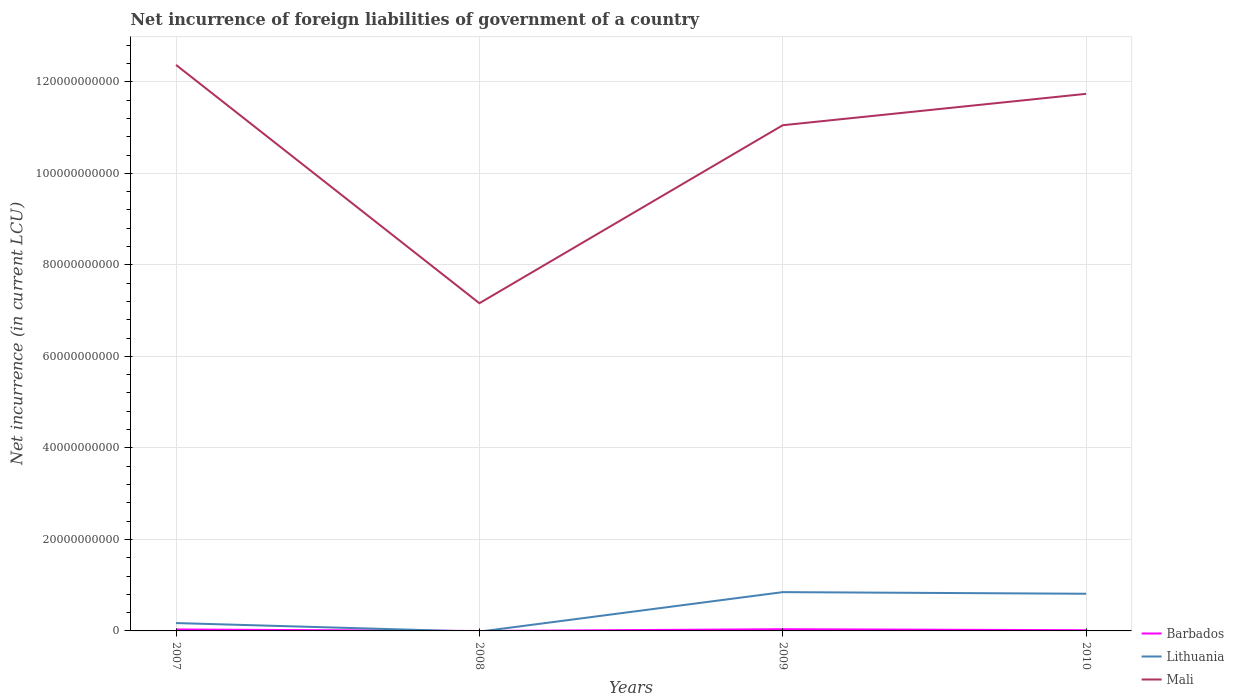How many different coloured lines are there?
Provide a succinct answer. 3. Across all years, what is the maximum net incurrence of foreign liabilities in Barbados?
Ensure brevity in your answer.  0. What is the total net incurrence of foreign liabilities in Mali in the graph?
Ensure brevity in your answer.  1.32e+1. What is the difference between the highest and the second highest net incurrence of foreign liabilities in Lithuania?
Give a very brief answer. 8.48e+09. What is the difference between the highest and the lowest net incurrence of foreign liabilities in Barbados?
Provide a succinct answer. 2. Is the net incurrence of foreign liabilities in Lithuania strictly greater than the net incurrence of foreign liabilities in Barbados over the years?
Give a very brief answer. No. What is the difference between two consecutive major ticks on the Y-axis?
Make the answer very short. 2.00e+1. Are the values on the major ticks of Y-axis written in scientific E-notation?
Offer a very short reply. No. Does the graph contain any zero values?
Ensure brevity in your answer.  Yes. Does the graph contain grids?
Give a very brief answer. Yes. How many legend labels are there?
Make the answer very short. 3. How are the legend labels stacked?
Offer a terse response. Vertical. What is the title of the graph?
Offer a terse response. Net incurrence of foreign liabilities of government of a country. Does "Turkey" appear as one of the legend labels in the graph?
Ensure brevity in your answer.  No. What is the label or title of the Y-axis?
Give a very brief answer. Net incurrence (in current LCU). What is the Net incurrence (in current LCU) in Barbados in 2007?
Your answer should be compact. 3.19e+08. What is the Net incurrence (in current LCU) in Lithuania in 2007?
Give a very brief answer. 1.72e+09. What is the Net incurrence (in current LCU) in Mali in 2007?
Keep it short and to the point. 1.24e+11. What is the Net incurrence (in current LCU) of Barbados in 2008?
Offer a terse response. 0. What is the Net incurrence (in current LCU) of Lithuania in 2008?
Keep it short and to the point. 0. What is the Net incurrence (in current LCU) of Mali in 2008?
Give a very brief answer. 7.16e+1. What is the Net incurrence (in current LCU) in Barbados in 2009?
Offer a very short reply. 3.75e+08. What is the Net incurrence (in current LCU) in Lithuania in 2009?
Offer a very short reply. 8.48e+09. What is the Net incurrence (in current LCU) of Mali in 2009?
Offer a terse response. 1.11e+11. What is the Net incurrence (in current LCU) of Barbados in 2010?
Keep it short and to the point. 1.54e+08. What is the Net incurrence (in current LCU) of Lithuania in 2010?
Offer a very short reply. 8.12e+09. What is the Net incurrence (in current LCU) of Mali in 2010?
Your answer should be very brief. 1.17e+11. Across all years, what is the maximum Net incurrence (in current LCU) of Barbados?
Your response must be concise. 3.75e+08. Across all years, what is the maximum Net incurrence (in current LCU) in Lithuania?
Provide a succinct answer. 8.48e+09. Across all years, what is the maximum Net incurrence (in current LCU) of Mali?
Provide a short and direct response. 1.24e+11. Across all years, what is the minimum Net incurrence (in current LCU) of Lithuania?
Provide a succinct answer. 0. Across all years, what is the minimum Net incurrence (in current LCU) of Mali?
Ensure brevity in your answer.  7.16e+1. What is the total Net incurrence (in current LCU) of Barbados in the graph?
Make the answer very short. 8.48e+08. What is the total Net incurrence (in current LCU) in Lithuania in the graph?
Keep it short and to the point. 1.83e+1. What is the total Net incurrence (in current LCU) in Mali in the graph?
Ensure brevity in your answer.  4.23e+11. What is the difference between the Net incurrence (in current LCU) of Mali in 2007 and that in 2008?
Your response must be concise. 5.21e+1. What is the difference between the Net incurrence (in current LCU) of Barbados in 2007 and that in 2009?
Your answer should be very brief. -5.55e+07. What is the difference between the Net incurrence (in current LCU) in Lithuania in 2007 and that in 2009?
Make the answer very short. -6.76e+09. What is the difference between the Net incurrence (in current LCU) in Mali in 2007 and that in 2009?
Your answer should be compact. 1.32e+1. What is the difference between the Net incurrence (in current LCU) in Barbados in 2007 and that in 2010?
Your answer should be very brief. 1.65e+08. What is the difference between the Net incurrence (in current LCU) of Lithuania in 2007 and that in 2010?
Make the answer very short. -6.40e+09. What is the difference between the Net incurrence (in current LCU) in Mali in 2007 and that in 2010?
Offer a terse response. 6.32e+09. What is the difference between the Net incurrence (in current LCU) of Mali in 2008 and that in 2009?
Offer a very short reply. -3.89e+1. What is the difference between the Net incurrence (in current LCU) in Mali in 2008 and that in 2010?
Provide a succinct answer. -4.58e+1. What is the difference between the Net incurrence (in current LCU) in Barbados in 2009 and that in 2010?
Give a very brief answer. 2.20e+08. What is the difference between the Net incurrence (in current LCU) in Lithuania in 2009 and that in 2010?
Provide a succinct answer. 3.56e+08. What is the difference between the Net incurrence (in current LCU) in Mali in 2009 and that in 2010?
Make the answer very short. -6.86e+09. What is the difference between the Net incurrence (in current LCU) in Barbados in 2007 and the Net incurrence (in current LCU) in Mali in 2008?
Ensure brevity in your answer.  -7.13e+1. What is the difference between the Net incurrence (in current LCU) of Lithuania in 2007 and the Net incurrence (in current LCU) of Mali in 2008?
Make the answer very short. -6.99e+1. What is the difference between the Net incurrence (in current LCU) of Barbados in 2007 and the Net incurrence (in current LCU) of Lithuania in 2009?
Offer a terse response. -8.16e+09. What is the difference between the Net incurrence (in current LCU) in Barbados in 2007 and the Net incurrence (in current LCU) in Mali in 2009?
Offer a terse response. -1.10e+11. What is the difference between the Net incurrence (in current LCU) in Lithuania in 2007 and the Net incurrence (in current LCU) in Mali in 2009?
Provide a succinct answer. -1.09e+11. What is the difference between the Net incurrence (in current LCU) in Barbados in 2007 and the Net incurrence (in current LCU) in Lithuania in 2010?
Your response must be concise. -7.80e+09. What is the difference between the Net incurrence (in current LCU) of Barbados in 2007 and the Net incurrence (in current LCU) of Mali in 2010?
Offer a terse response. -1.17e+11. What is the difference between the Net incurrence (in current LCU) of Lithuania in 2007 and the Net incurrence (in current LCU) of Mali in 2010?
Provide a succinct answer. -1.16e+11. What is the difference between the Net incurrence (in current LCU) of Barbados in 2009 and the Net incurrence (in current LCU) of Lithuania in 2010?
Ensure brevity in your answer.  -7.75e+09. What is the difference between the Net incurrence (in current LCU) of Barbados in 2009 and the Net incurrence (in current LCU) of Mali in 2010?
Ensure brevity in your answer.  -1.17e+11. What is the difference between the Net incurrence (in current LCU) in Lithuania in 2009 and the Net incurrence (in current LCU) in Mali in 2010?
Offer a terse response. -1.09e+11. What is the average Net incurrence (in current LCU) of Barbados per year?
Your answer should be very brief. 2.12e+08. What is the average Net incurrence (in current LCU) in Lithuania per year?
Keep it short and to the point. 4.58e+09. What is the average Net incurrence (in current LCU) in Mali per year?
Keep it short and to the point. 1.06e+11. In the year 2007, what is the difference between the Net incurrence (in current LCU) in Barbados and Net incurrence (in current LCU) in Lithuania?
Keep it short and to the point. -1.40e+09. In the year 2007, what is the difference between the Net incurrence (in current LCU) in Barbados and Net incurrence (in current LCU) in Mali?
Keep it short and to the point. -1.23e+11. In the year 2007, what is the difference between the Net incurrence (in current LCU) in Lithuania and Net incurrence (in current LCU) in Mali?
Your answer should be compact. -1.22e+11. In the year 2009, what is the difference between the Net incurrence (in current LCU) in Barbados and Net incurrence (in current LCU) in Lithuania?
Provide a succinct answer. -8.10e+09. In the year 2009, what is the difference between the Net incurrence (in current LCU) in Barbados and Net incurrence (in current LCU) in Mali?
Offer a very short reply. -1.10e+11. In the year 2009, what is the difference between the Net incurrence (in current LCU) in Lithuania and Net incurrence (in current LCU) in Mali?
Offer a terse response. -1.02e+11. In the year 2010, what is the difference between the Net incurrence (in current LCU) of Barbados and Net incurrence (in current LCU) of Lithuania?
Offer a very short reply. -7.97e+09. In the year 2010, what is the difference between the Net incurrence (in current LCU) in Barbados and Net incurrence (in current LCU) in Mali?
Provide a short and direct response. -1.17e+11. In the year 2010, what is the difference between the Net incurrence (in current LCU) of Lithuania and Net incurrence (in current LCU) of Mali?
Offer a very short reply. -1.09e+11. What is the ratio of the Net incurrence (in current LCU) in Mali in 2007 to that in 2008?
Your answer should be very brief. 1.73. What is the ratio of the Net incurrence (in current LCU) in Barbados in 2007 to that in 2009?
Keep it short and to the point. 0.85. What is the ratio of the Net incurrence (in current LCU) in Lithuania in 2007 to that in 2009?
Offer a terse response. 0.2. What is the ratio of the Net incurrence (in current LCU) in Mali in 2007 to that in 2009?
Your answer should be compact. 1.12. What is the ratio of the Net incurrence (in current LCU) in Barbados in 2007 to that in 2010?
Provide a succinct answer. 2.07. What is the ratio of the Net incurrence (in current LCU) of Lithuania in 2007 to that in 2010?
Ensure brevity in your answer.  0.21. What is the ratio of the Net incurrence (in current LCU) of Mali in 2007 to that in 2010?
Your answer should be very brief. 1.05. What is the ratio of the Net incurrence (in current LCU) of Mali in 2008 to that in 2009?
Provide a short and direct response. 0.65. What is the ratio of the Net incurrence (in current LCU) in Mali in 2008 to that in 2010?
Give a very brief answer. 0.61. What is the ratio of the Net incurrence (in current LCU) of Barbados in 2009 to that in 2010?
Offer a terse response. 2.43. What is the ratio of the Net incurrence (in current LCU) of Lithuania in 2009 to that in 2010?
Provide a short and direct response. 1.04. What is the ratio of the Net incurrence (in current LCU) of Mali in 2009 to that in 2010?
Offer a terse response. 0.94. What is the difference between the highest and the second highest Net incurrence (in current LCU) in Barbados?
Make the answer very short. 5.55e+07. What is the difference between the highest and the second highest Net incurrence (in current LCU) in Lithuania?
Offer a terse response. 3.56e+08. What is the difference between the highest and the second highest Net incurrence (in current LCU) of Mali?
Keep it short and to the point. 6.32e+09. What is the difference between the highest and the lowest Net incurrence (in current LCU) in Barbados?
Give a very brief answer. 3.75e+08. What is the difference between the highest and the lowest Net incurrence (in current LCU) of Lithuania?
Keep it short and to the point. 8.48e+09. What is the difference between the highest and the lowest Net incurrence (in current LCU) of Mali?
Your answer should be compact. 5.21e+1. 